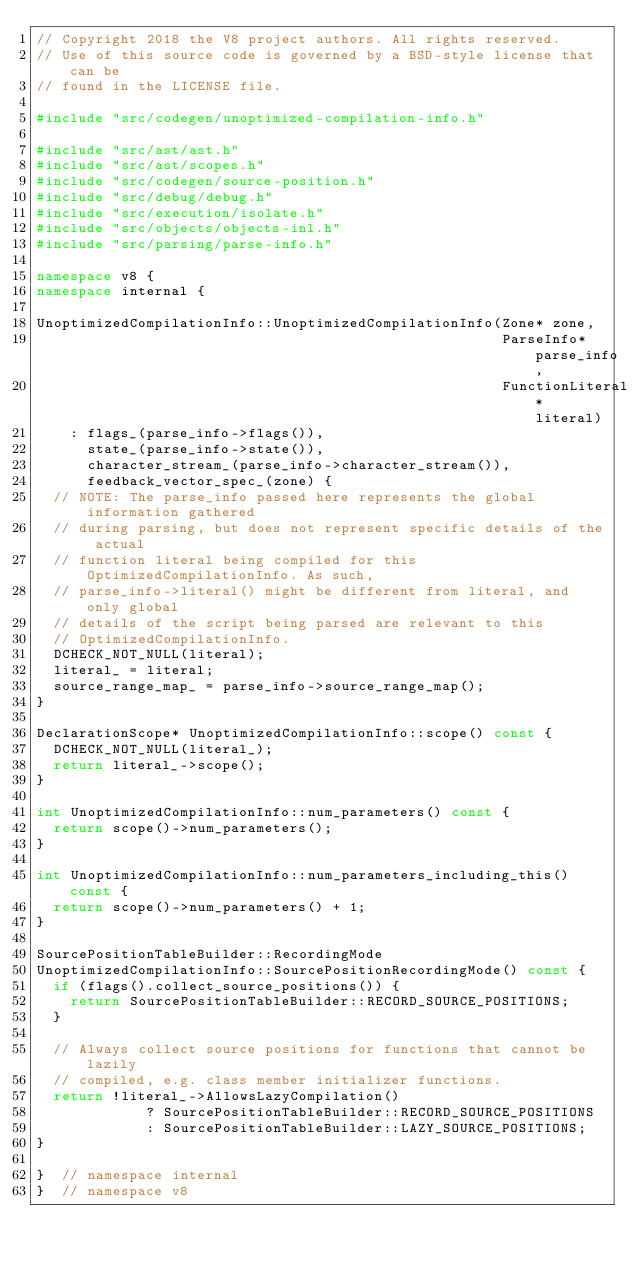<code> <loc_0><loc_0><loc_500><loc_500><_C++_>// Copyright 2018 the V8 project authors. All rights reserved.
// Use of this source code is governed by a BSD-style license that can be
// found in the LICENSE file.

#include "src/codegen/unoptimized-compilation-info.h"

#include "src/ast/ast.h"
#include "src/ast/scopes.h"
#include "src/codegen/source-position.h"
#include "src/debug/debug.h"
#include "src/execution/isolate.h"
#include "src/objects/objects-inl.h"
#include "src/parsing/parse-info.h"

namespace v8 {
namespace internal {

UnoptimizedCompilationInfo::UnoptimizedCompilationInfo(Zone* zone,
                                                       ParseInfo* parse_info,
                                                       FunctionLiteral* literal)
    : flags_(parse_info->flags()),
      state_(parse_info->state()),
      character_stream_(parse_info->character_stream()),
      feedback_vector_spec_(zone) {
  // NOTE: The parse_info passed here represents the global information gathered
  // during parsing, but does not represent specific details of the actual
  // function literal being compiled for this OptimizedCompilationInfo. As such,
  // parse_info->literal() might be different from literal, and only global
  // details of the script being parsed are relevant to this
  // OptimizedCompilationInfo.
  DCHECK_NOT_NULL(literal);
  literal_ = literal;
  source_range_map_ = parse_info->source_range_map();
}

DeclarationScope* UnoptimizedCompilationInfo::scope() const {
  DCHECK_NOT_NULL(literal_);
  return literal_->scope();
}

int UnoptimizedCompilationInfo::num_parameters() const {
  return scope()->num_parameters();
}

int UnoptimizedCompilationInfo::num_parameters_including_this() const {
  return scope()->num_parameters() + 1;
}

SourcePositionTableBuilder::RecordingMode
UnoptimizedCompilationInfo::SourcePositionRecordingMode() const {
  if (flags().collect_source_positions()) {
    return SourcePositionTableBuilder::RECORD_SOURCE_POSITIONS;
  }

  // Always collect source positions for functions that cannot be lazily
  // compiled, e.g. class member initializer functions.
  return !literal_->AllowsLazyCompilation()
             ? SourcePositionTableBuilder::RECORD_SOURCE_POSITIONS
             : SourcePositionTableBuilder::LAZY_SOURCE_POSITIONS;
}

}  // namespace internal
}  // namespace v8
</code> 